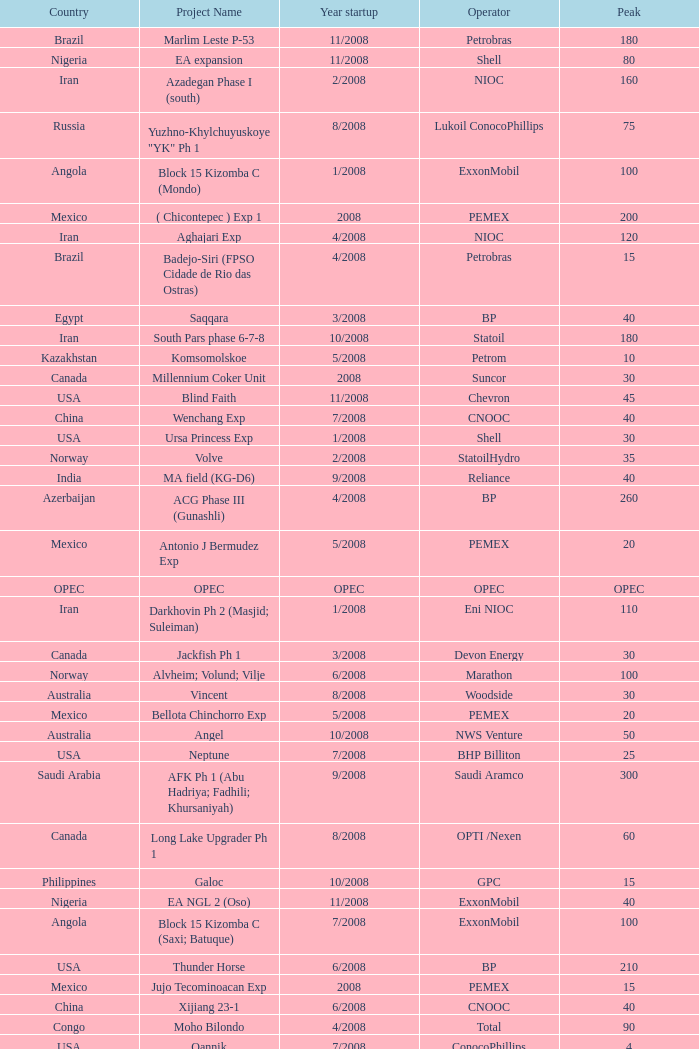What is the Operator with a Peak that is 55? PEMEX. 